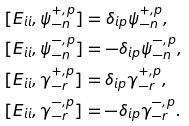Convert formula to latex. <formula><loc_0><loc_0><loc_500><loc_500>& [ E _ { i i } , \psi ^ { + , p } _ { - n } ] = \delta _ { i p } \psi ^ { + , p } _ { - n } , \\ & [ E _ { i i } , \psi ^ { - , p } _ { - n } ] = - \delta _ { i p } \psi ^ { - , p } _ { - n } , \\ & [ E _ { i i } , \gamma ^ { + , p } _ { - r } ] = \delta _ { i p } \gamma ^ { + , p } _ { - r } , \\ & [ E _ { i i } , \gamma ^ { - , p } _ { - r } ] = - \delta _ { i p } \gamma ^ { - , p } _ { - r } .</formula> 